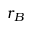<formula> <loc_0><loc_0><loc_500><loc_500>r _ { B }</formula> 